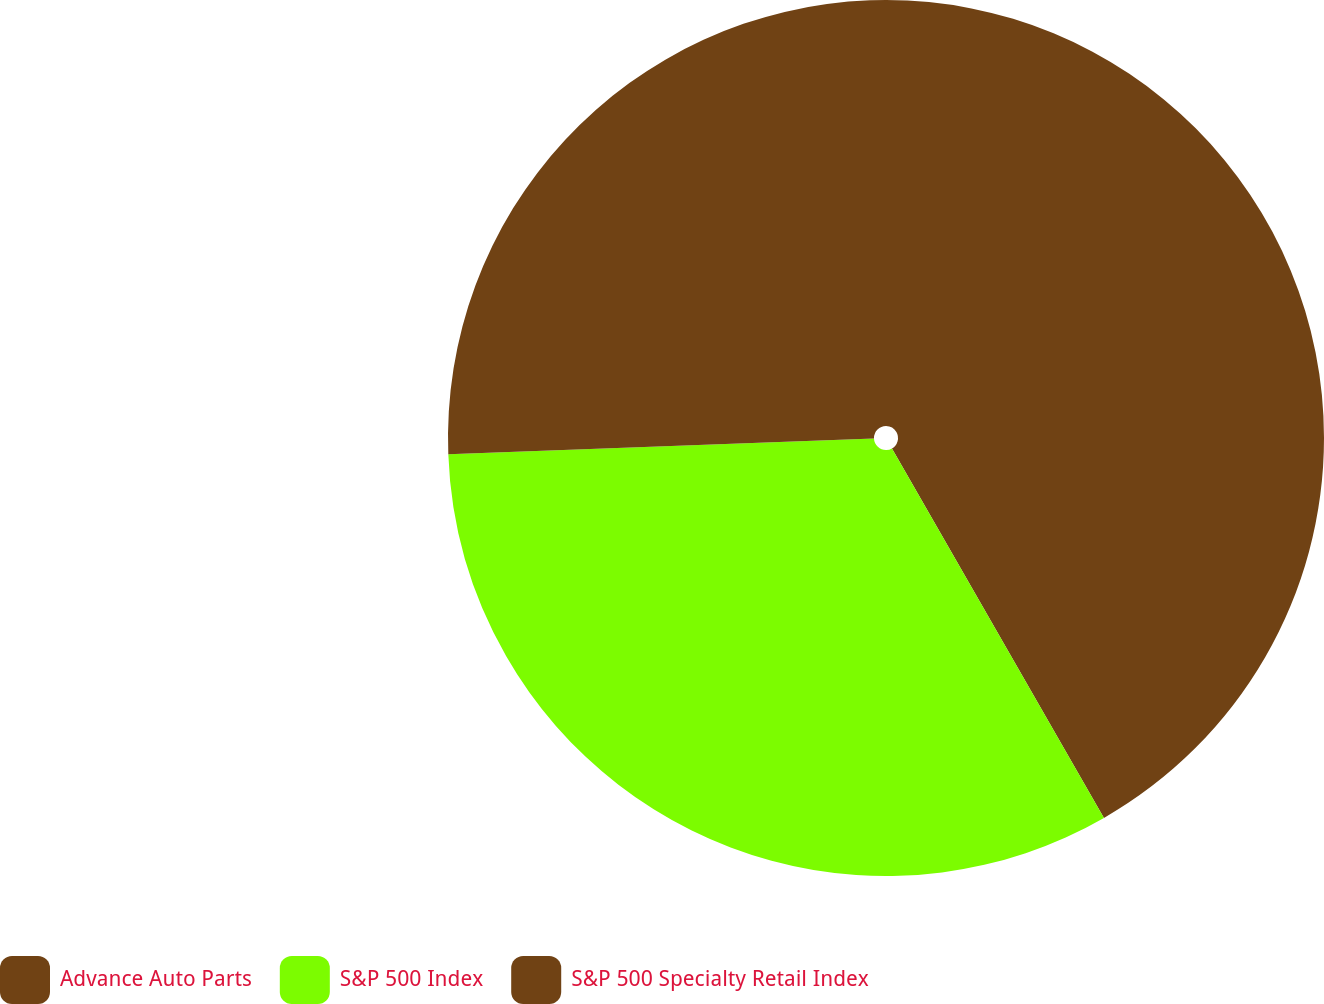Convert chart to OTSL. <chart><loc_0><loc_0><loc_500><loc_500><pie_chart><fcel>Advance Auto Parts<fcel>S&P 500 Index<fcel>S&P 500 Specialty Retail Index<nl><fcel>41.71%<fcel>32.7%<fcel>25.59%<nl></chart> 